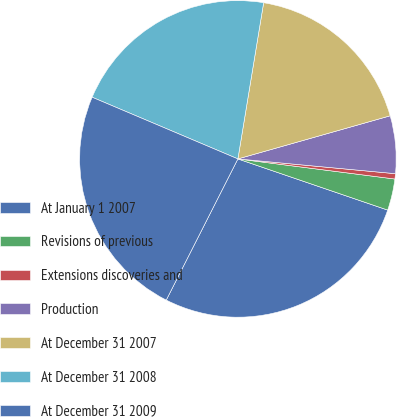Convert chart to OTSL. <chart><loc_0><loc_0><loc_500><loc_500><pie_chart><fcel>At January 1 2007<fcel>Revisions of previous<fcel>Extensions discoveries and<fcel>Production<fcel>At December 31 2007<fcel>At December 31 2008<fcel>At December 31 2009<nl><fcel>27.24%<fcel>3.21%<fcel>0.54%<fcel>5.88%<fcel>18.01%<fcel>21.23%<fcel>23.9%<nl></chart> 